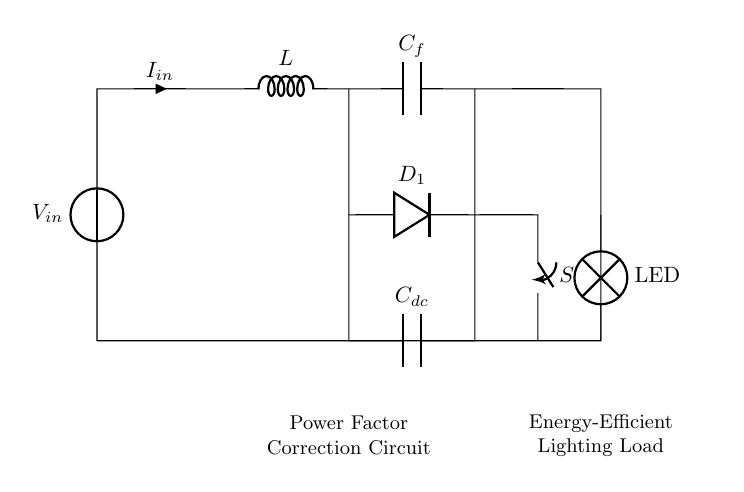What type of circuit is this? This circuit is a power factor correction circuit, as indicated in the label. It is designed to improve the efficiency of the lighting system by correcting power factor issues.
Answer: Power factor correction circuit What components are present in the circuit? The circuit contains a voltage source, inductor, capacitor, diode, switch, and LED lamp. These components are essential for the functioning of the power factor correction system.
Answer: Voltage source, inductor, capacitor, diode, switch, LED What is the function of the capacitor labeled C_f? The capacitor C_f is used for power factor correction, helping to balance the inductive effects of the load. This component improves the overall efficiency of the circuit.
Answer: Power factor correction What is the purpose of the diode labeled D_1? The diode D_1 allows current to flow in one direction, protecting the circuit from potential backflow of current which can damage other components.
Answer: Prevent backflow of current How does the inductor affect the circuit? The inductor stores energy in a magnetic field when current flows through it, which can help to delay the current and improve the overall power factor in the circuit.
Answer: Delays current, improves power factor What does the switch labeled S control? The switch S controls the connection between the capacitor C_dc and the circuit, allowing the user to enable or disable this part of the circuit as needed.
Answer: Connects/disconnects capacitor 